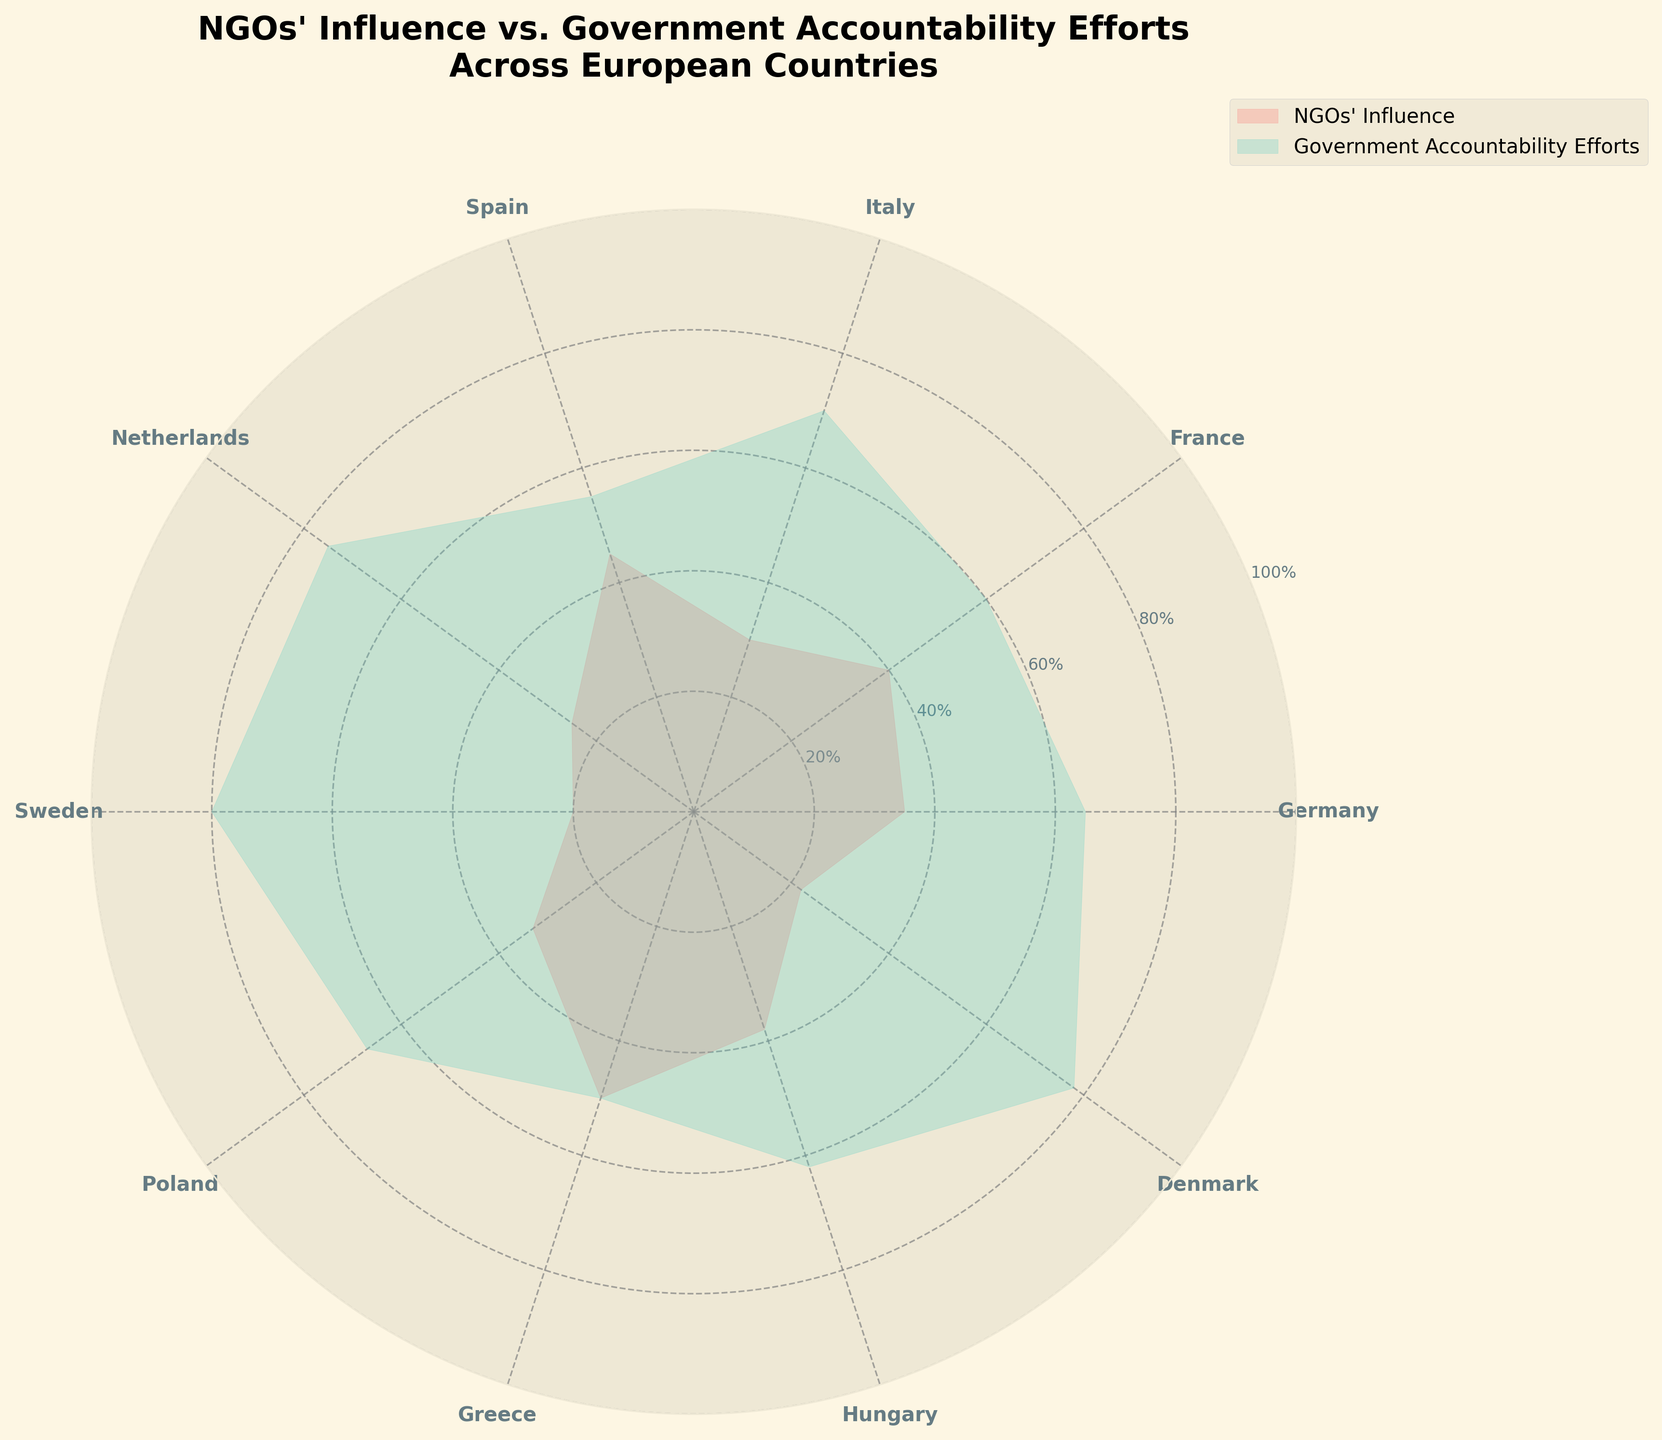What's the title of the figure? The title is located at the top of the chart, indicated in bold font.
Answer: NGOs' Influence vs. Government Accountability Efforts Across European Countries How many countries are included in the plot? Count each distinct label on the angular tick labels in the figure.
Answer: 10 Which country has the highest NGOs' influence? Identify the country label where the red region extends the furthest from the center.
Answer: Greece What is the difference in NGOs' influence between Spain and the Netherlands? Look at the length of the red segments for Spain and the Netherlands, subtract the Netherlands' value from Spain's value (45-25).
Answer: 20 What is the average government accountability effort across all countries? Add all the green segment lengths and divide by the number of countries: (65+60+70+55+75+80+67+50+62+78) / 10 = 66.2%
Answer: 66.2% Which country has the closest balance between NGOs' influence and government accountability efforts? Identify the country where the red and green segments have the closest lengths.
Answer: Greece Are there more countries where government accountability efforts exceed NGOs' influence or vice versa? Compare the green and red segment lengths for each country, count which type is greater. Government accountability efforts are greater in more countries.
Answer: Government accountability efforts What is the range of NGOs' influence percentages? Find the difference between the maximum and minimum values of the red segments (50-20).
Answer: 30% Which country has the smallest NGOs' influence and what is the value? Identify the country with the shortest red segment and read its percentage.
Answer: Sweden, 20% Is the NGOs' influence generally higher or lower than government accountability efforts across the countries? Compare the overall spread and average lengths of the red and green segments. The green segments (government accountability efforts) are generally longer than the red segments (NGOs' influence).
Answer: Lower 